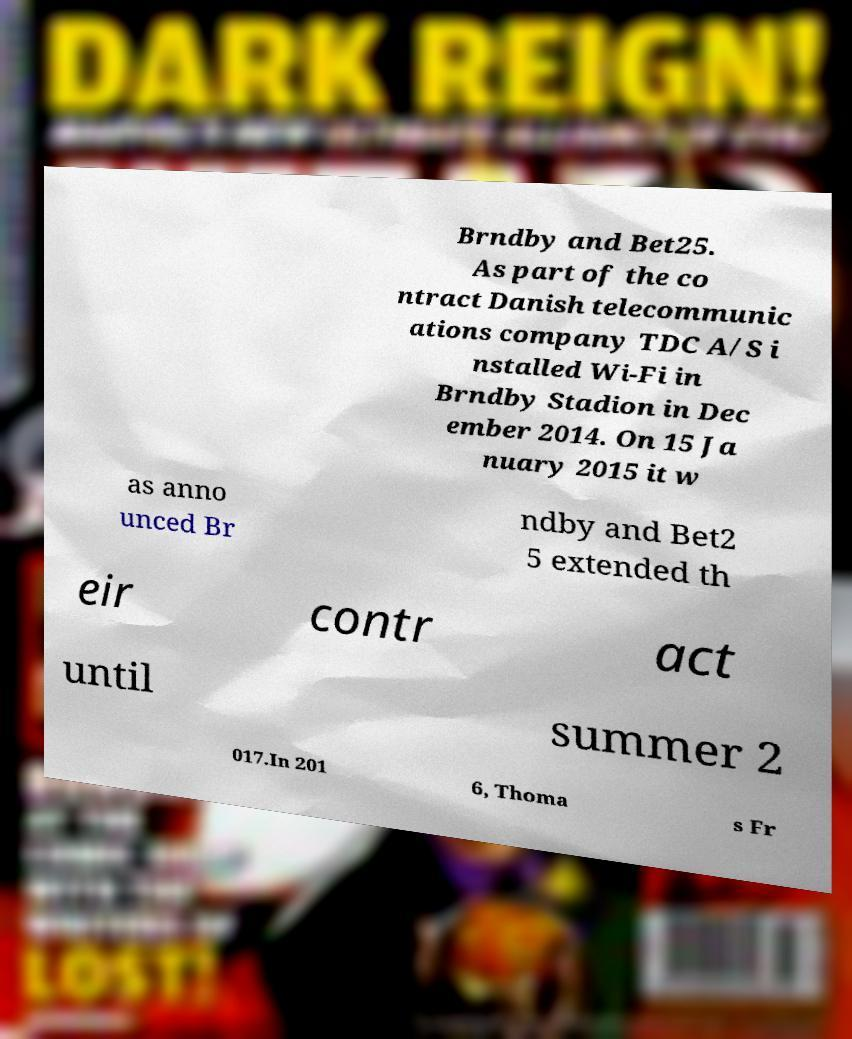What messages or text are displayed in this image? I need them in a readable, typed format. Brndby and Bet25. As part of the co ntract Danish telecommunic ations company TDC A/S i nstalled Wi-Fi in Brndby Stadion in Dec ember 2014. On 15 Ja nuary 2015 it w as anno unced Br ndby and Bet2 5 extended th eir contr act until summer 2 017.In 201 6, Thoma s Fr 